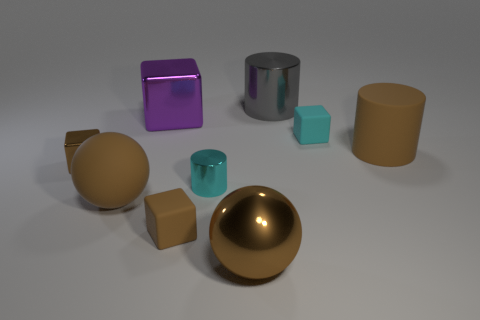Subtract all big metallic cubes. How many cubes are left? 3 Subtract 1 cylinders. How many cylinders are left? 2 Subtract all cyan blocks. How many blocks are left? 3 Add 1 small purple matte things. How many objects exist? 10 Subtract all red spheres. Subtract all red blocks. How many spheres are left? 2 Subtract all purple spheres. How many gray cylinders are left? 1 Subtract all objects. Subtract all tiny green rubber cylinders. How many objects are left? 0 Add 8 gray metal things. How many gray metal things are left? 9 Add 8 big blocks. How many big blocks exist? 9 Subtract 2 brown blocks. How many objects are left? 7 